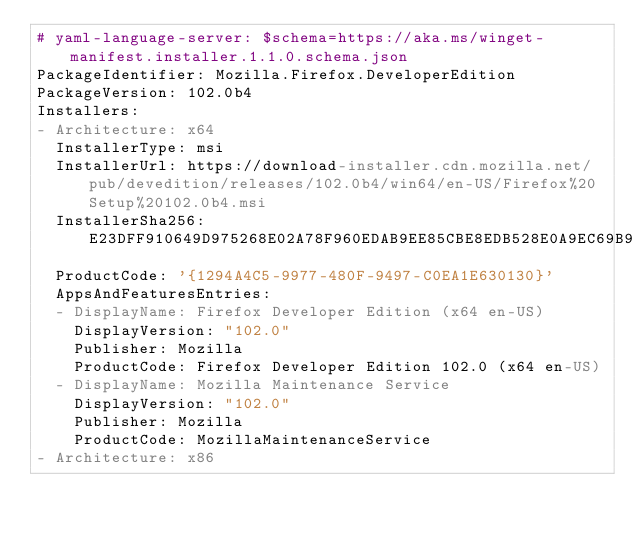<code> <loc_0><loc_0><loc_500><loc_500><_YAML_># yaml-language-server: $schema=https://aka.ms/winget-manifest.installer.1.1.0.schema.json
PackageIdentifier: Mozilla.Firefox.DeveloperEdition
PackageVersion: 102.0b4
Installers:
- Architecture: x64
  InstallerType: msi
  InstallerUrl: https://download-installer.cdn.mozilla.net/pub/devedition/releases/102.0b4/win64/en-US/Firefox%20Setup%20102.0b4.msi
  InstallerSha256: E23DFF910649D975268E02A78F960EDAB9EE85CBE8EDB528E0A9EC69B904F478
  ProductCode: '{1294A4C5-9977-480F-9497-C0EA1E630130}'
  AppsAndFeaturesEntries:
  - DisplayName: Firefox Developer Edition (x64 en-US)
    DisplayVersion: "102.0"
    Publisher: Mozilla
    ProductCode: Firefox Developer Edition 102.0 (x64 en-US)
  - DisplayName: Mozilla Maintenance Service
    DisplayVersion: "102.0"
    Publisher: Mozilla
    ProductCode: MozillaMaintenanceService
- Architecture: x86</code> 